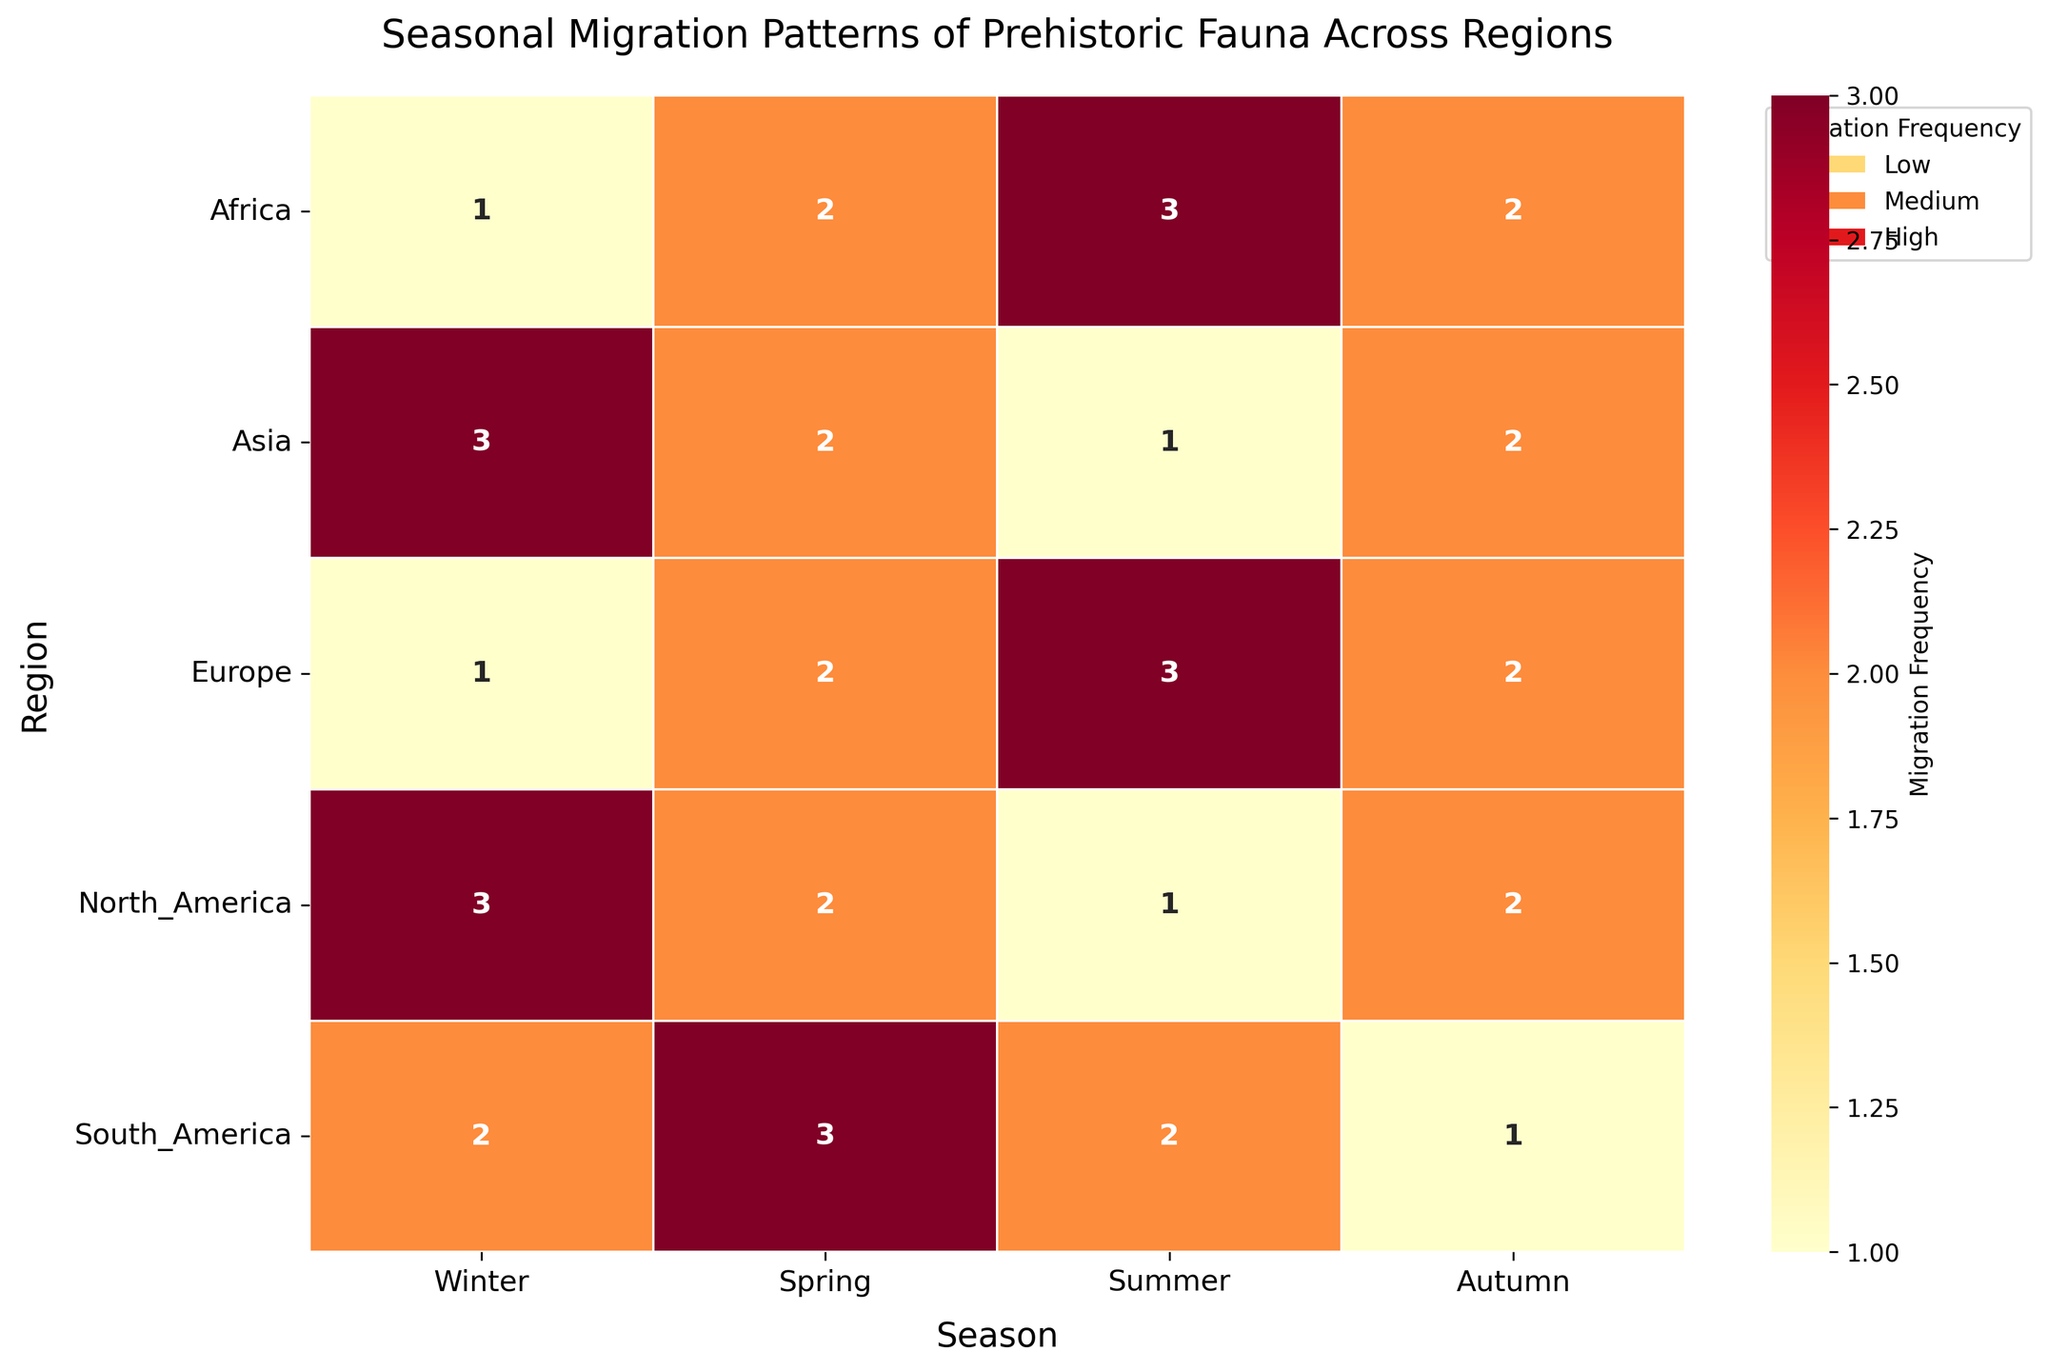What is the title of the heatmap? The title is placed at the top center of the heatmap.
Answer: Seasonal Migration Patterns of Prehistoric Fauna Across Regions Which region and season combination shows the highest migration frequency for Megaloceros_giganteus? Locate Megaloceros_giganteus in the data (which migrates in Asia) and find its highest migration frequency value across the seasons in the heatmap. The season with the highest migration value of 'High' (3) is Winter.
Answer: Asia, Winter How many regions exhibit medium migration frequency in the summer? Identify the "Medium" migration frequency value (2) in the summer column and count the number of regions (rows) that display this value. The regions are North America and South America.
Answer: 2 Which region has the least variation in migration frequency across seasons? Observe each region's migration frequencies across all seasons and identify the one with the least change. Europe has frequencies ranging from Low (1) to High (3), but Asia also has frequencies from Low (1) to High (3). Assessing further, all regions show variability.
Answer: None, all show variability In which season does Loxodonta_atlantica have the highest migration frequency? Loxodonta_atlantica migrates in Africa, find the highest migration frequency value among the seasons. The highest value of 'High' (3) is in Summer.
Answer: Summer What is the average migration frequency for Mammuthus_primigenius over all seasons? Add the migration frequency values for Mammuthus_primigenius across all seasons and divide by the number of seasons. High (3) + Medium (2) + Low (1) + Medium (2) = 8, average is 8/4 = 2.
Answer: 2 Which season has the highest overall migration frequency? Sum the migration frequencies for each season across all regions and identify the season with the highest total. Winter (1+1+3+1+2 = 8), Spring (2+2+2+2+3 = 11), Summer (1+3+1+3+2 = 10), Autumn (2+2+2+2+1 = 9). Spring has the highest total of 11.
Answer: Spring Is there any region where the migration frequency remains constant through all seasons? Check each region's migration frequencies across all seasons for uniform values. None, all have varying frequencies.
Answer: No Between Panthera_leo_spelaea and Smilodon_populator, which species shows a higher variation in migration frequency across all seasons? Calculate the range (difference between max and min values) of migration frequencies for both species. Panthera_leo_spelaea (in Europe) has Low to High (1 to 3), range = 2. Smilodon_populator (in South America) has Low to High (1 to 3), range = 2.
Answer: Equal variation Which region and species combination exhibits the highest frequency of migration during spring? Look at the Spring column and identify the highest migration frequency value and refer to the corresponding region and species. Smilodon_populator in South America has the highest migration frequency of High (3).
Answer: South America, Smilodon_populator 